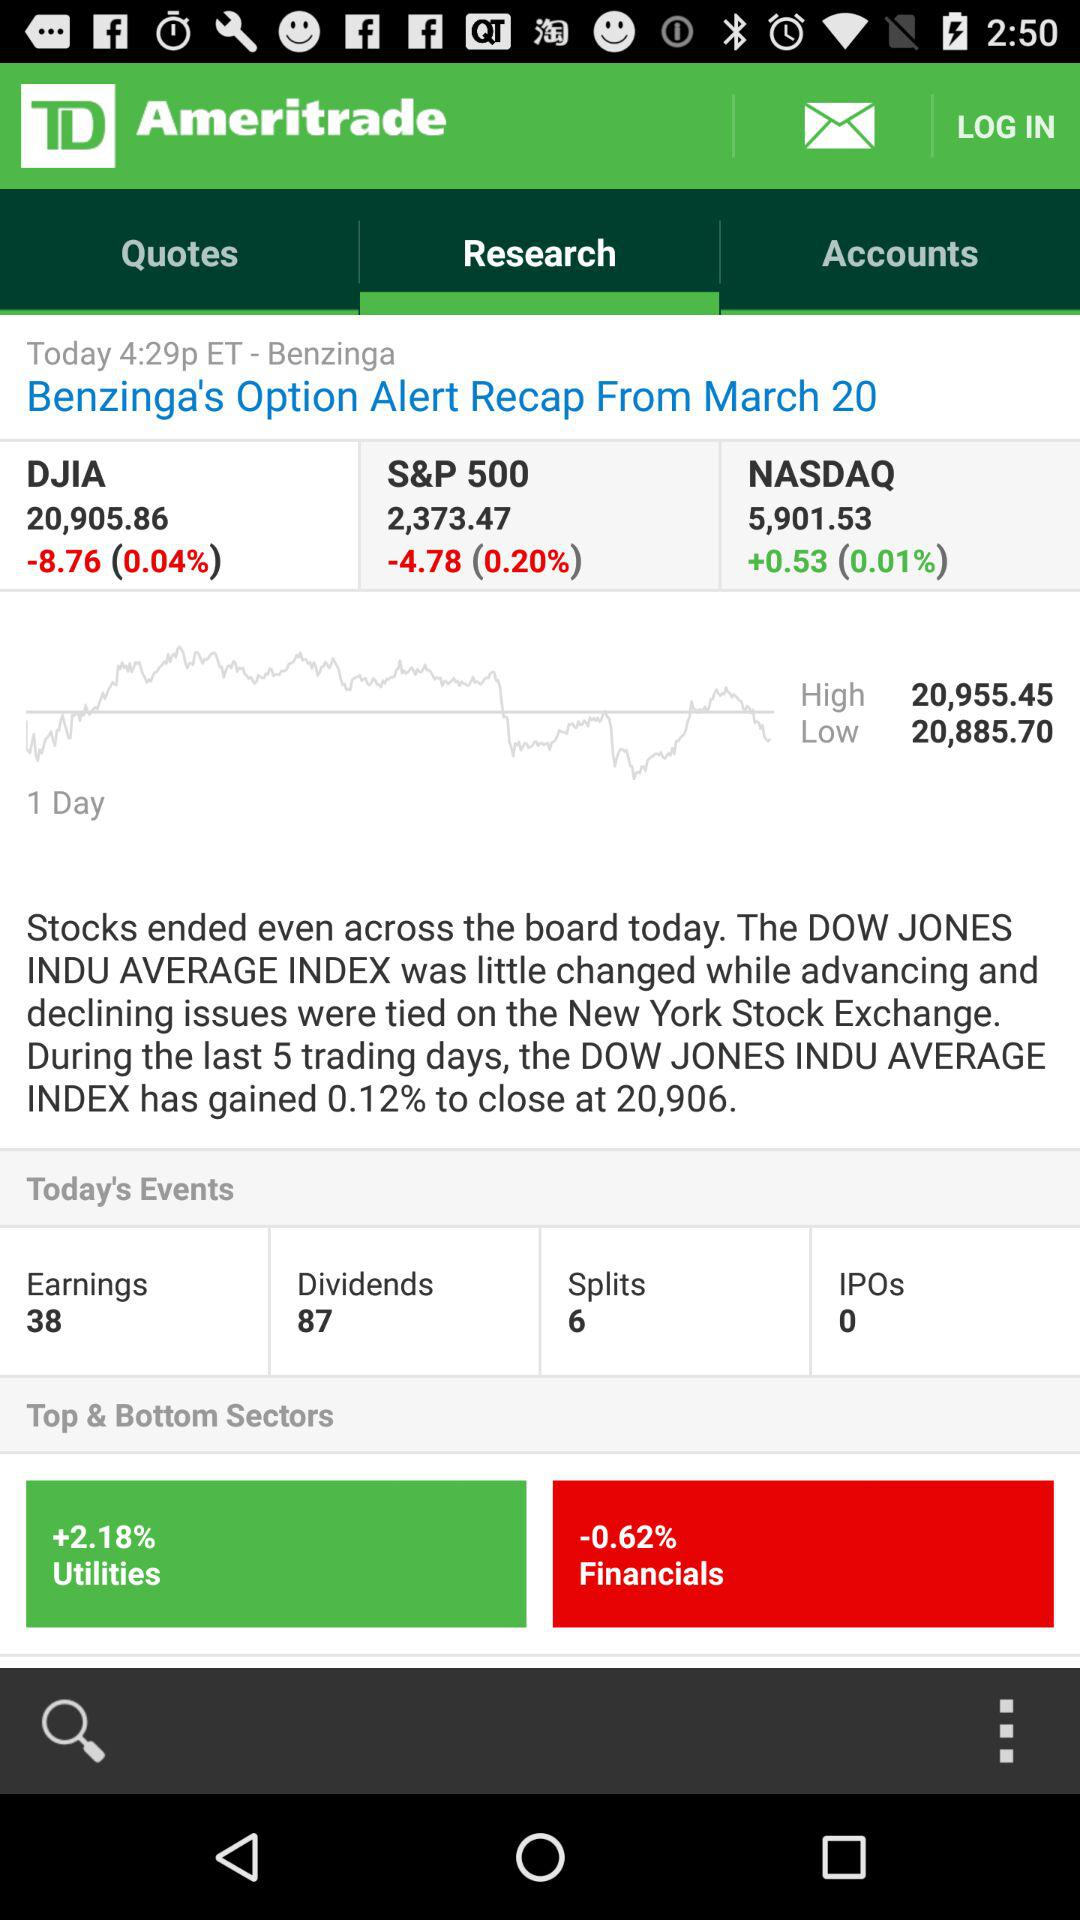What is the number of earnings? The number of earning is 38. 